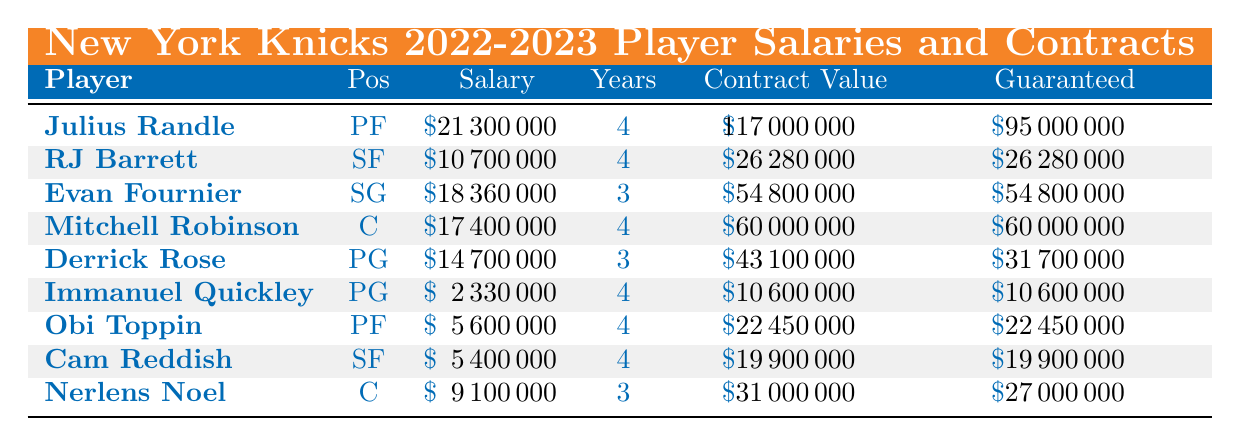What is Julius Randle's salary for the 2022-2023 season? The table shows that Julius Randle's salary is listed under the Salary column, which states $21,300,000.
Answer: 21,300,000 How many years is Mitchell Robinson's contract? According to the table, the number of years for Mitchell Robinson's contract is found in the Years column, which states 4.
Answer: 4 Is RJ Barrett's contract fully guaranteed? The Guaranteed column for RJ Barrett shows $26,280,000, which matches his Contract Value, indicating that the entire contract is fully guaranteed.
Answer: Yes What is the total salary of all players listed in the table? The salaries in the table are: 21,300,000 (Randle) + 10,700,000 (Barrett) + 18,360,000 (Fournier) + 17,400,000 (Robinson) + 14,700,000 (Rose) + 2,330,000 (Quickley) + 5,600,000 (Toppin) + 5,400,000 (Reddish) + 9,100,000 (Noel) = 105,300,000. Thus, the total salary is $105,300,000.
Answer: 105,300,000 Which player has the highest guaranteed money in their contract? By comparing the Guaranteed column across all players, Julius Randle has $95,000,000 as the highest guaranteed money in his contract, higher than all others listed.
Answer: Julius Randle How many players have a contract value greater than 50 million? Looking at the Contract Value column: Randle ($117,000,000), Fournier ($54,800,000), and Robinson ($60,000,000) are the only players with contract values greater than 50 million. So, there are three players.
Answer: 3 What is the average salary of all the players on this list? The salaries are 21,300,000 (Randle), 10,700,000 (Barrett), 18,360,000 (Fournier), 17,400,000 (Robinson), 14,700,000 (Rose), 2,330,000 (Quickley), 5,600,000 (Toppin), 5,400,000 (Reddish), and 9,100,000 (Noel). The total is 105,300,000, and there are 9 players, so the average salary is 105,300,000 / 9 = 11,700,000.
Answer: 11,700,000 Is Derrick Rose's salary less than Mitchell Robinson's salary? Derrick Rose's salary is $14,700,000, which is greater than Mitchell Robinson's salary of $17,400,000. Therefore, it is false.
Answer: No 